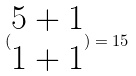<formula> <loc_0><loc_0><loc_500><loc_500>( \begin{matrix} 5 + 1 \\ 1 + 1 \end{matrix} ) = 1 5</formula> 